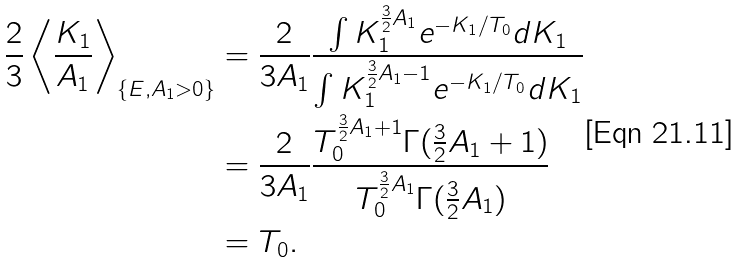<formula> <loc_0><loc_0><loc_500><loc_500>\frac { 2 } { 3 } \left \langle \frac { K _ { 1 } } { A _ { 1 } } \right \rangle _ { \{ E , A _ { 1 } > 0 \} } & = \frac { 2 } { 3 A _ { 1 } } \frac { \int K _ { 1 } ^ { \frac { 3 } { 2 } A _ { 1 } } e ^ { - K _ { 1 } / T _ { 0 } } d K _ { 1 } } { \int K _ { 1 } ^ { \frac { 3 } { 2 } A _ { 1 } - 1 } e ^ { - K _ { 1 } / T _ { 0 } } d K _ { 1 } } \\ & = \frac { 2 } { 3 A _ { 1 } } \frac { T _ { 0 } ^ { \frac { 3 } { 2 } A _ { 1 } + 1 } \Gamma ( \frac { 3 } { 2 } A _ { 1 } + 1 ) } { T _ { 0 } ^ { \frac { 3 } { 2 } A _ { 1 } } \Gamma ( \frac { 3 } { 2 } A _ { 1 } ) } \\ & = T _ { 0 } .</formula> 